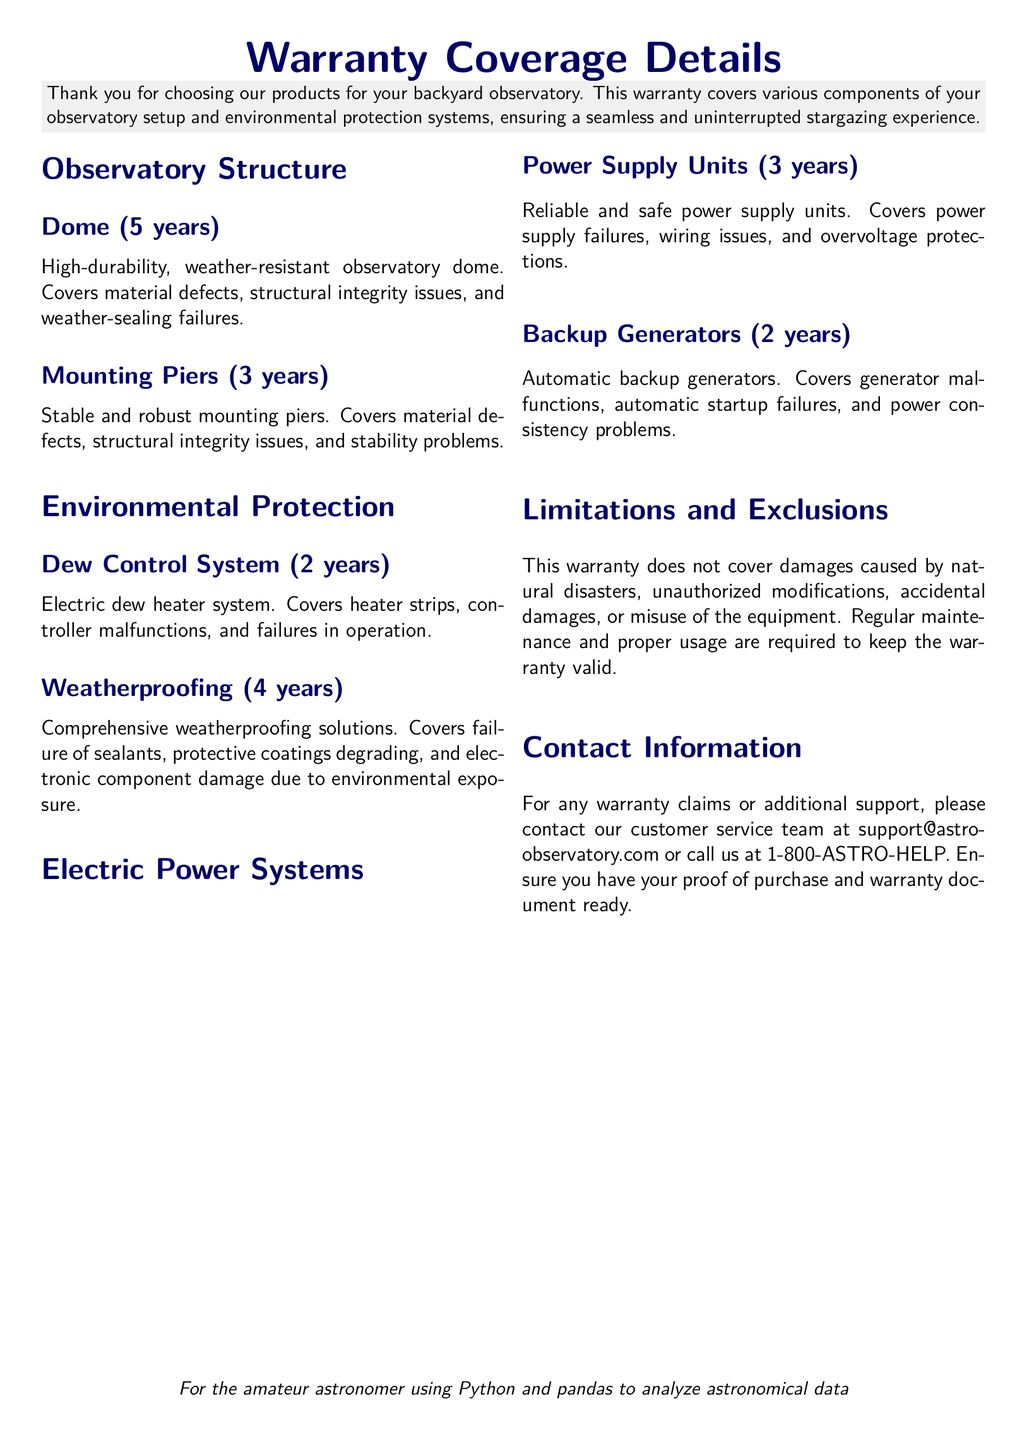What is the warranty period for the dome? The warranty period for the dome is stated in the document, which is 5 years.
Answer: 5 years What components are covered under the environmental protection section? The environmental protection section covers Dew Control System and Weatherproofing as outlined in the document.
Answer: Dew Control System and Weatherproofing What does the warranty not cover? The document lists certain exclusions, including damages caused by natural disasters and unauthorized modifications.
Answer: Natural disasters, unauthorized modifications How long is the warranty for backup generators? The warranty period for backup generators is mentioned in the document, which is 2 years.
Answer: 2 years What is the warranty coverage for power supply units? The document specifies that the power supply units have a warranty coverage of 3 years.
Answer: 3 years What should be kept to make the warranty valid? The document mentions that proof of purchase and warranty document should be kept to maintain the warranty validity.
Answer: Proof of purchase and warranty document Which environmental protection system has the shortest warranty period? According to the document, the Dew Control System has the shortest warranty period, which is 2 years.
Answer: Dew Control System What is the email address for customer support? The document provides a contact email for customer support, which is provided to assist with warranty claims.
Answer: support@astro-observatory.com 